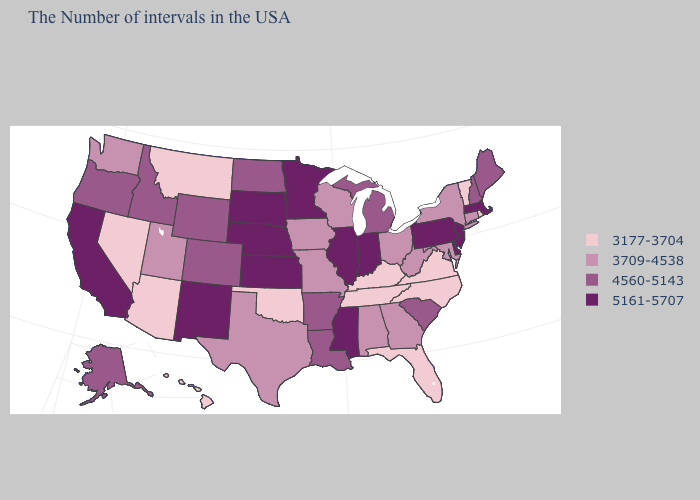Among the states that border Maryland , which have the lowest value?
Give a very brief answer. Virginia. Does Indiana have the highest value in the MidWest?
Short answer required. Yes. Does Alabama have the lowest value in the USA?
Keep it brief. No. Which states have the lowest value in the USA?
Write a very short answer. Rhode Island, Vermont, Virginia, North Carolina, Florida, Kentucky, Tennessee, Oklahoma, Montana, Arizona, Nevada, Hawaii. What is the value of Massachusetts?
Quick response, please. 5161-5707. Name the states that have a value in the range 3709-4538?
Quick response, please. Connecticut, New York, Maryland, West Virginia, Ohio, Georgia, Alabama, Wisconsin, Missouri, Iowa, Texas, Utah, Washington. Is the legend a continuous bar?
Short answer required. No. What is the highest value in the USA?
Concise answer only. 5161-5707. Which states have the lowest value in the USA?
Answer briefly. Rhode Island, Vermont, Virginia, North Carolina, Florida, Kentucky, Tennessee, Oklahoma, Montana, Arizona, Nevada, Hawaii. How many symbols are there in the legend?
Be succinct. 4. Does the map have missing data?
Write a very short answer. No. Does New Mexico have the highest value in the West?
Concise answer only. Yes. What is the value of South Dakota?
Be succinct. 5161-5707. What is the lowest value in the West?
Answer briefly. 3177-3704. Name the states that have a value in the range 3709-4538?
Keep it brief. Connecticut, New York, Maryland, West Virginia, Ohio, Georgia, Alabama, Wisconsin, Missouri, Iowa, Texas, Utah, Washington. 